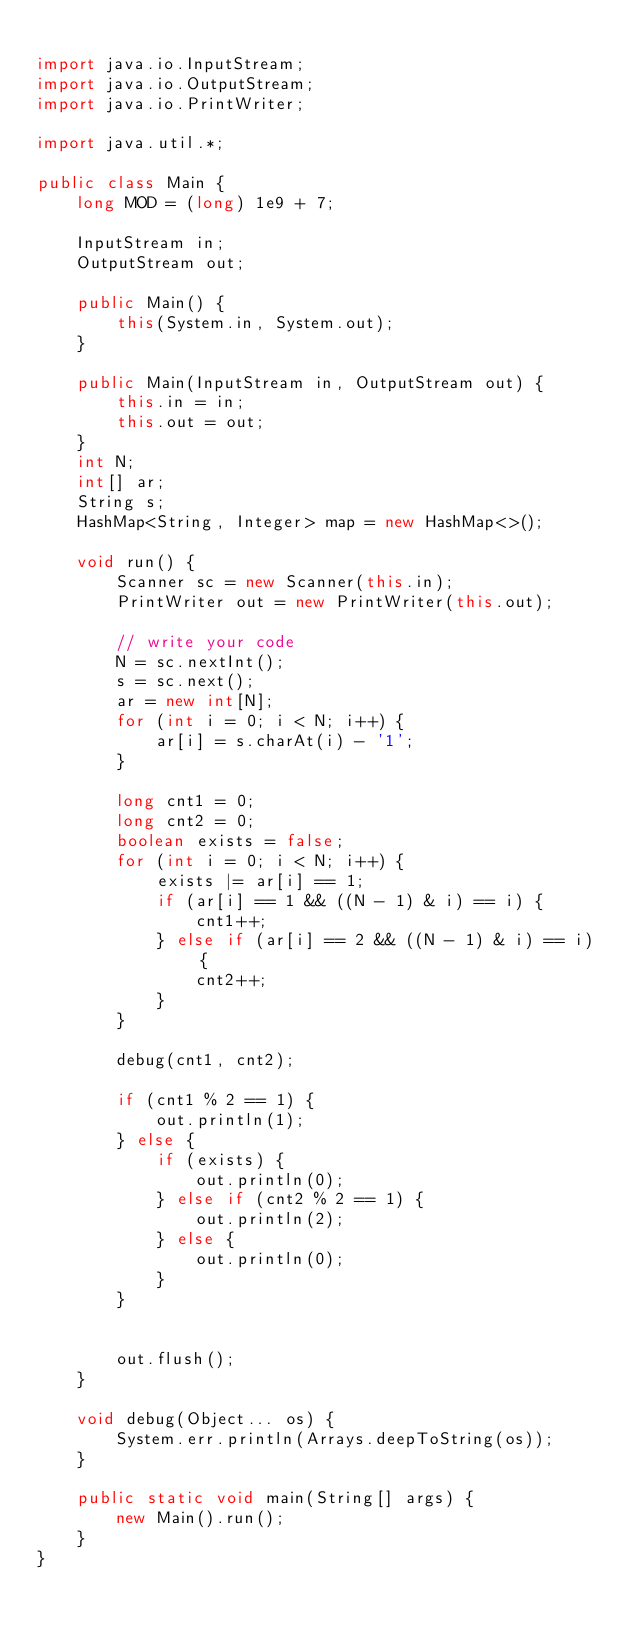Convert code to text. <code><loc_0><loc_0><loc_500><loc_500><_Java_>
import java.io.InputStream;
import java.io.OutputStream;
import java.io.PrintWriter;

import java.util.*;

public class Main {
    long MOD = (long) 1e9 + 7;

    InputStream in;
    OutputStream out;

    public Main() {
        this(System.in, System.out);
    }

    public Main(InputStream in, OutputStream out) {
        this.in = in;
        this.out = out;
    }
    int N;
    int[] ar;
    String s;
    HashMap<String, Integer> map = new HashMap<>();

    void run() {
        Scanner sc = new Scanner(this.in);
        PrintWriter out = new PrintWriter(this.out);

        // write your code
        N = sc.nextInt();
        s = sc.next();
        ar = new int[N];
        for (int i = 0; i < N; i++) {
            ar[i] = s.charAt(i) - '1';
        }

        long cnt1 = 0;
        long cnt2 = 0;
        boolean exists = false;
        for (int i = 0; i < N; i++) {
            exists |= ar[i] == 1;
            if (ar[i] == 1 && ((N - 1) & i) == i) {
                cnt1++;
            } else if (ar[i] == 2 && ((N - 1) & i) == i)  {
                cnt2++;
            }
        }

        debug(cnt1, cnt2);

        if (cnt1 % 2 == 1) {
            out.println(1);
        } else {
            if (exists) {
                out.println(0);
            } else if (cnt2 % 2 == 1) {
                out.println(2);
            } else {
                out.println(0);
            }
        }


        out.flush();
    }

    void debug(Object... os) {
        System.err.println(Arrays.deepToString(os));
    }

    public static void main(String[] args) {
        new Main().run();
    }
}</code> 